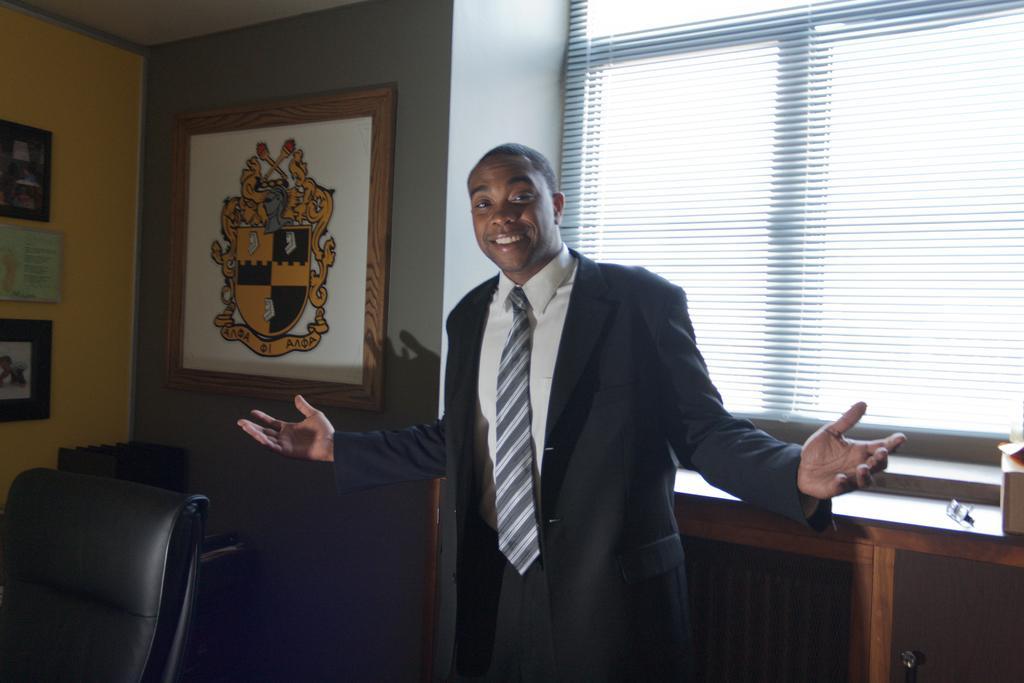Can you describe this image briefly? As we can see in the image, there is a man standing and smiling. On the left side there is a chair and there are four frames on wall. Behind him there is a window. 